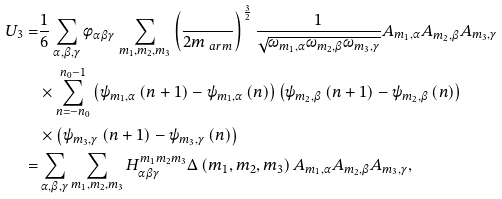Convert formula to latex. <formula><loc_0><loc_0><loc_500><loc_500>U _ { 3 } = & \frac { 1 } { 6 } \sum _ { \alpha , \beta , \gamma } \phi _ { \alpha \beta \gamma } \sum _ { m _ { 1 } , m _ { 2 } , m _ { 3 } } \left ( \frac { } { 2 m _ { \ a r m } } \right ) ^ { \frac { 3 } { 2 } } \frac { 1 } { \sqrt { \omega _ { m _ { 1 } , \alpha } \omega _ { m _ { 2 } , \beta } \omega _ { m _ { 3 } , \gamma } } } A _ { m _ { 1 } , \alpha } A _ { m _ { 2 } , \beta } A _ { m _ { 3 } , \gamma } \\ & \times \sum _ { n = - n _ { 0 } } ^ { n _ { 0 } - 1 } \left ( \psi _ { m _ { 1 } , \alpha } \left ( n + 1 \right ) - \psi _ { m _ { 1 } , \alpha } \left ( n \right ) \right ) \left ( \psi _ { m _ { 2 } , \beta } \left ( n + 1 \right ) - \psi _ { m _ { 2 } , \beta } \left ( n \right ) \right ) \\ & \times \left ( \psi _ { m _ { 3 } , \gamma } \left ( n + 1 \right ) - \psi _ { m _ { 3 } , \gamma } \left ( n \right ) \right ) \\ = & \sum _ { \alpha , \beta , \gamma } \sum _ { m _ { 1 } , m _ { 2 } , m _ { 3 } } H _ { \alpha \beta \gamma } ^ { m _ { 1 } m _ { 2 } m _ { 3 } } \Delta \left ( m _ { 1 } , m _ { 2 } , m _ { 3 } \right ) A _ { m _ { 1 } , \alpha } A _ { m _ { 2 } , \beta } A _ { m _ { 3 } , \gamma } ,</formula> 